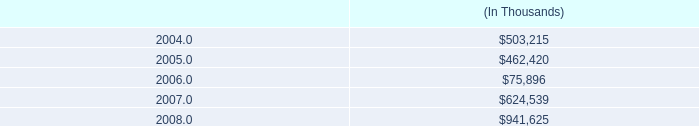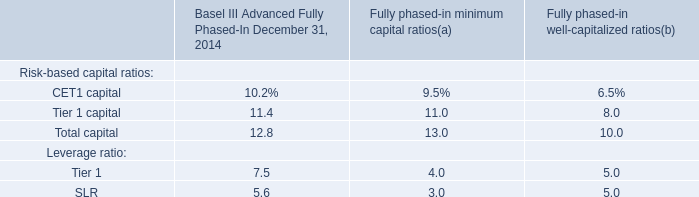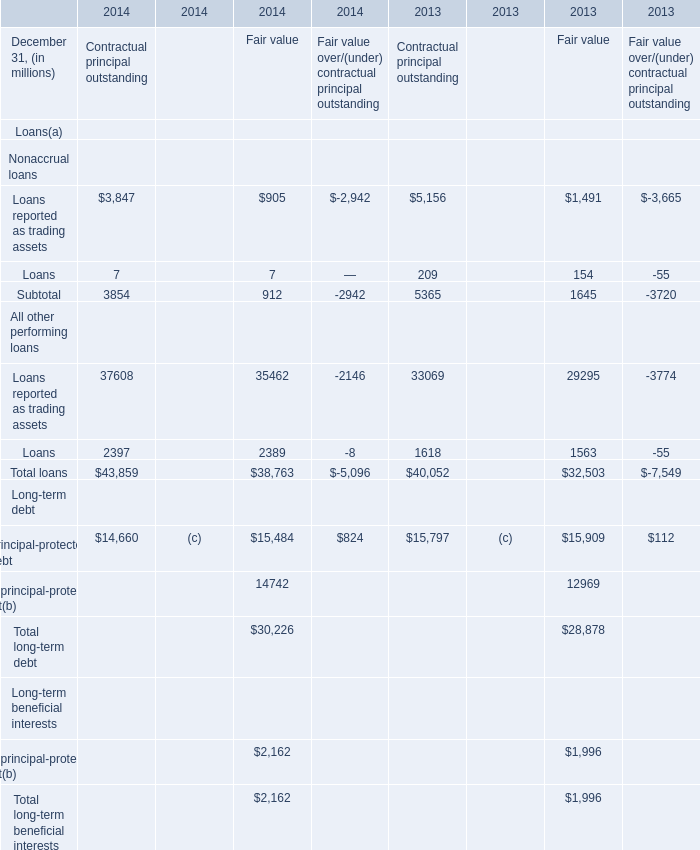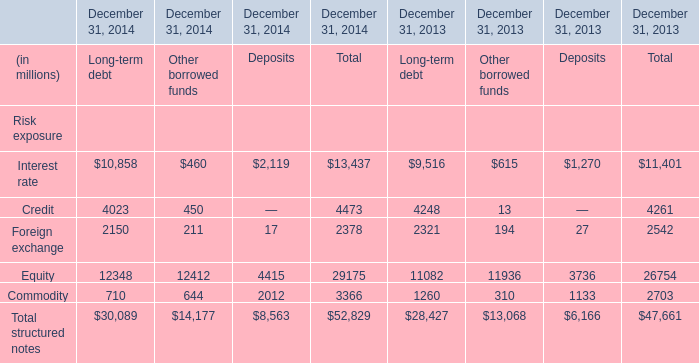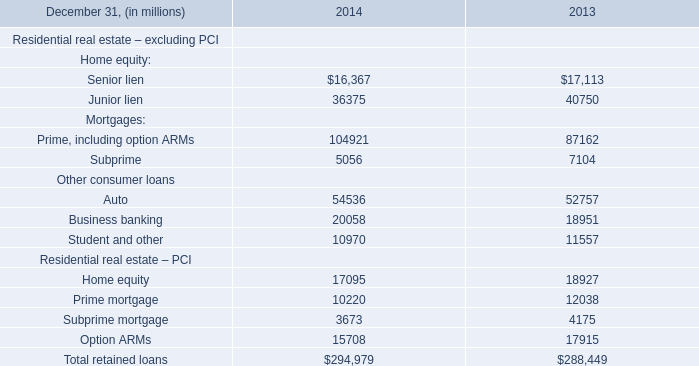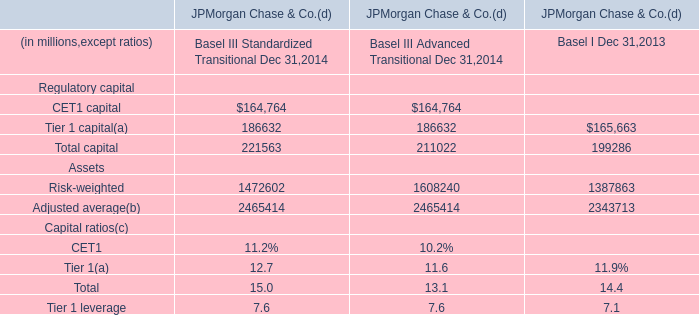Which Other borrowed funds occupies the greatest proportion in total amount in 2014? 
Answer: Equity. 